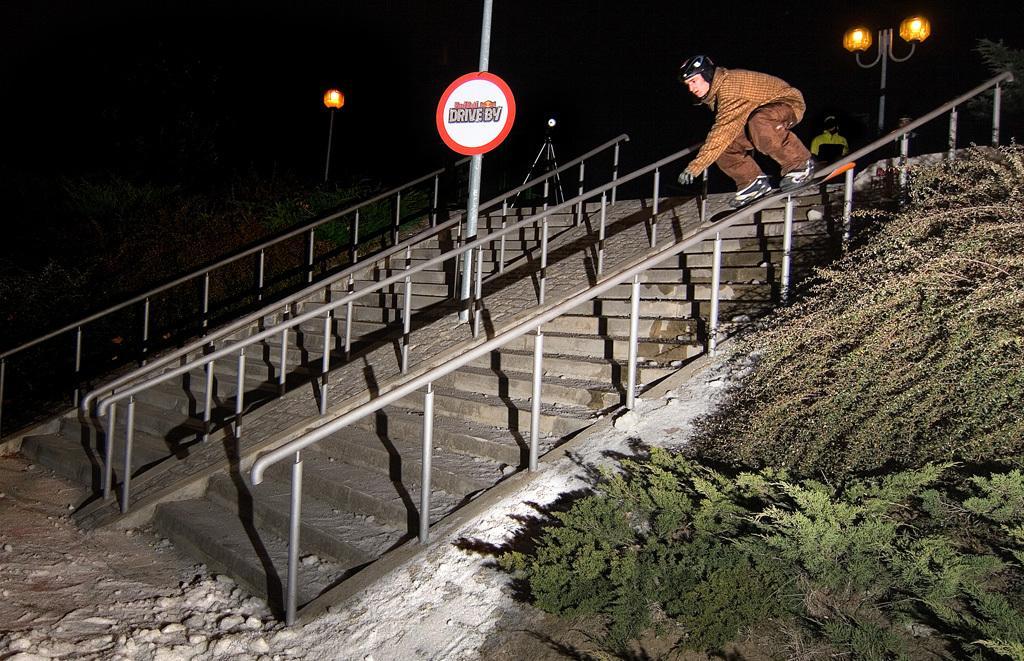Please provide a concise description of this image. The picture is taken at night time. On the right, there are trees and plants. In the center of the picture there are railings, pole and a person skating. On the left there are stones and stand. In the background there are lights and people. The background is dark. 